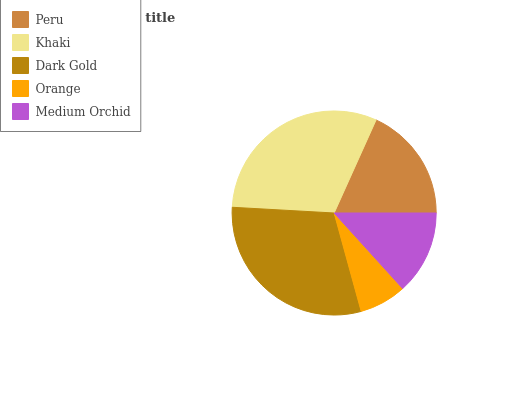Is Orange the minimum?
Answer yes or no. Yes. Is Khaki the maximum?
Answer yes or no. Yes. Is Dark Gold the minimum?
Answer yes or no. No. Is Dark Gold the maximum?
Answer yes or no. No. Is Khaki greater than Dark Gold?
Answer yes or no. Yes. Is Dark Gold less than Khaki?
Answer yes or no. Yes. Is Dark Gold greater than Khaki?
Answer yes or no. No. Is Khaki less than Dark Gold?
Answer yes or no. No. Is Peru the high median?
Answer yes or no. Yes. Is Peru the low median?
Answer yes or no. Yes. Is Orange the high median?
Answer yes or no. No. Is Dark Gold the low median?
Answer yes or no. No. 